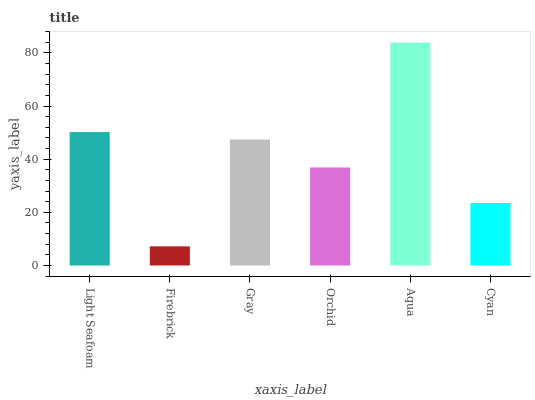Is Firebrick the minimum?
Answer yes or no. Yes. Is Aqua the maximum?
Answer yes or no. Yes. Is Gray the minimum?
Answer yes or no. No. Is Gray the maximum?
Answer yes or no. No. Is Gray greater than Firebrick?
Answer yes or no. Yes. Is Firebrick less than Gray?
Answer yes or no. Yes. Is Firebrick greater than Gray?
Answer yes or no. No. Is Gray less than Firebrick?
Answer yes or no. No. Is Gray the high median?
Answer yes or no. Yes. Is Orchid the low median?
Answer yes or no. Yes. Is Cyan the high median?
Answer yes or no. No. Is Aqua the low median?
Answer yes or no. No. 